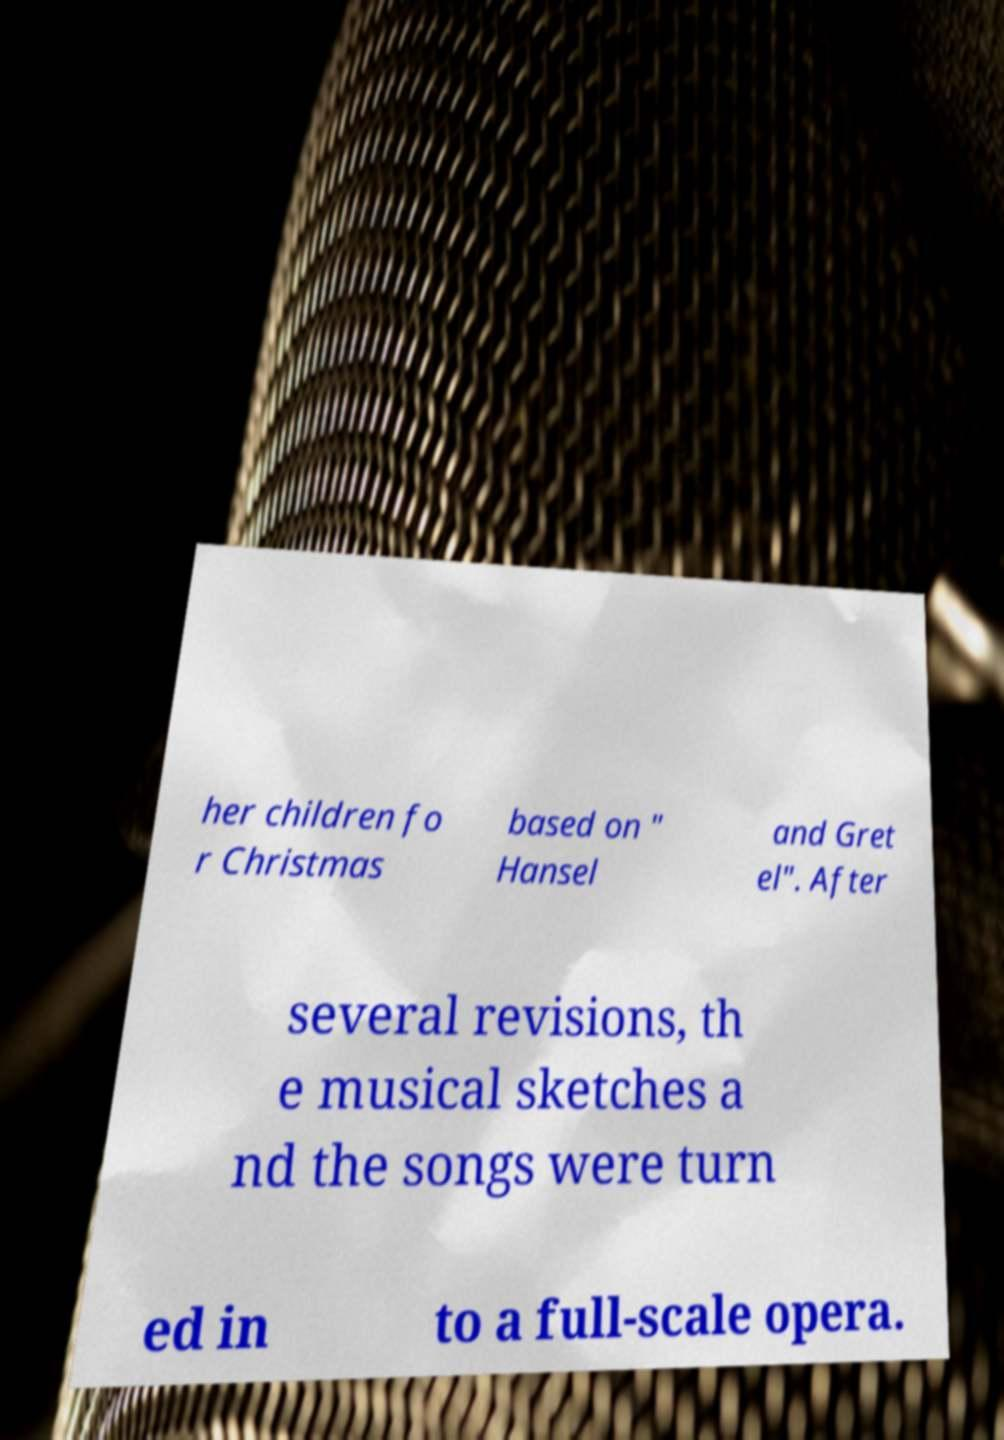Could you assist in decoding the text presented in this image and type it out clearly? her children fo r Christmas based on " Hansel and Gret el". After several revisions, th e musical sketches a nd the songs were turn ed in to a full-scale opera. 